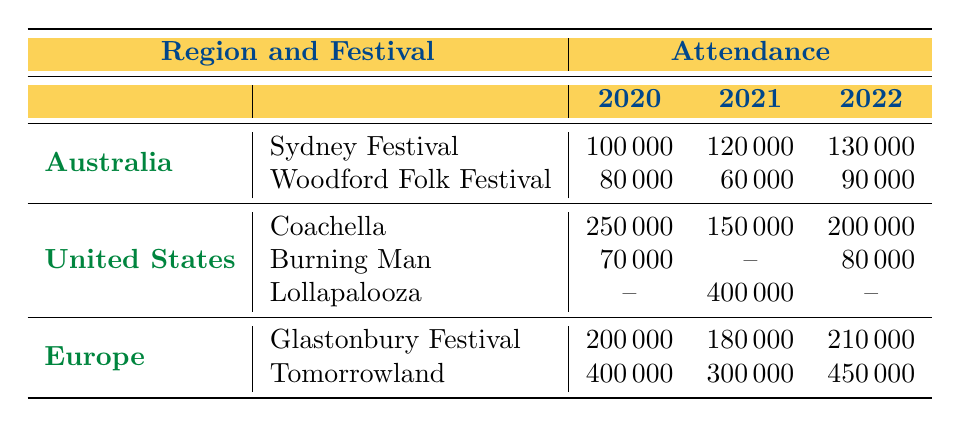What was the attendance for the Sydney Festival in 2021? In the 2021 row for Australia, under Sydney Festival, the Attendance value is 120000.
Answer: 120000 What is the attendance change for the Woodford Folk Festival from 2020 to 2022? The attendance in 2020 was 80000 and in 2022 it was 90000. The change can be calculated as 90000 - 80000 = 10000.
Answer: 10000 Did the attendance for Coachella increase or decrease from 2020 to 2021? In 2020, Coachella had an attendance of 250000, and in 2021, it decreased to 150000, indicating a decline.
Answer: Decrease Which festival had the highest attendance in 2022, and what was the number? In 2022, Tomorrowland had the highest attendance of 450000 compared to all other festivals listed in the table.
Answer: Tomorrowland, 450000 What is the average attendance for festivals in Australia over the three years? The attendance values for Australia over the three years are: 100000 (2020), 120000 (2021), and 130000 (2022). Summing these gives: 100000 + 120000 + 130000 = 350000. To find the average, divide by the number of years: 350000 / 3 = 116666.67. Rounded, the average is approximately 116667.
Answer: 116667 How many festivals in the United States had an attendance of over 200000 in 2021? In 2021, only Lollapalooza had an attendance of 400000, while Coachella had an attendance of 150000 and Burning Man had no attendance. So, only one festival had over 200000 attendees.
Answer: 1 What was the difference in attendance between Glastonbury Festival in 2020 and in 2021? Glastonbury Festival had an attendance of 200000 in 2020 and 180000 in 2021. The difference is 200000 - 180000 = 20000.
Answer: 20000 Was the attendance for Tomorrowland in 2021 higher than 300000? Tomorrowland had an attendance of 300000 in 2021, so it was not higher than that number.
Answer: No 